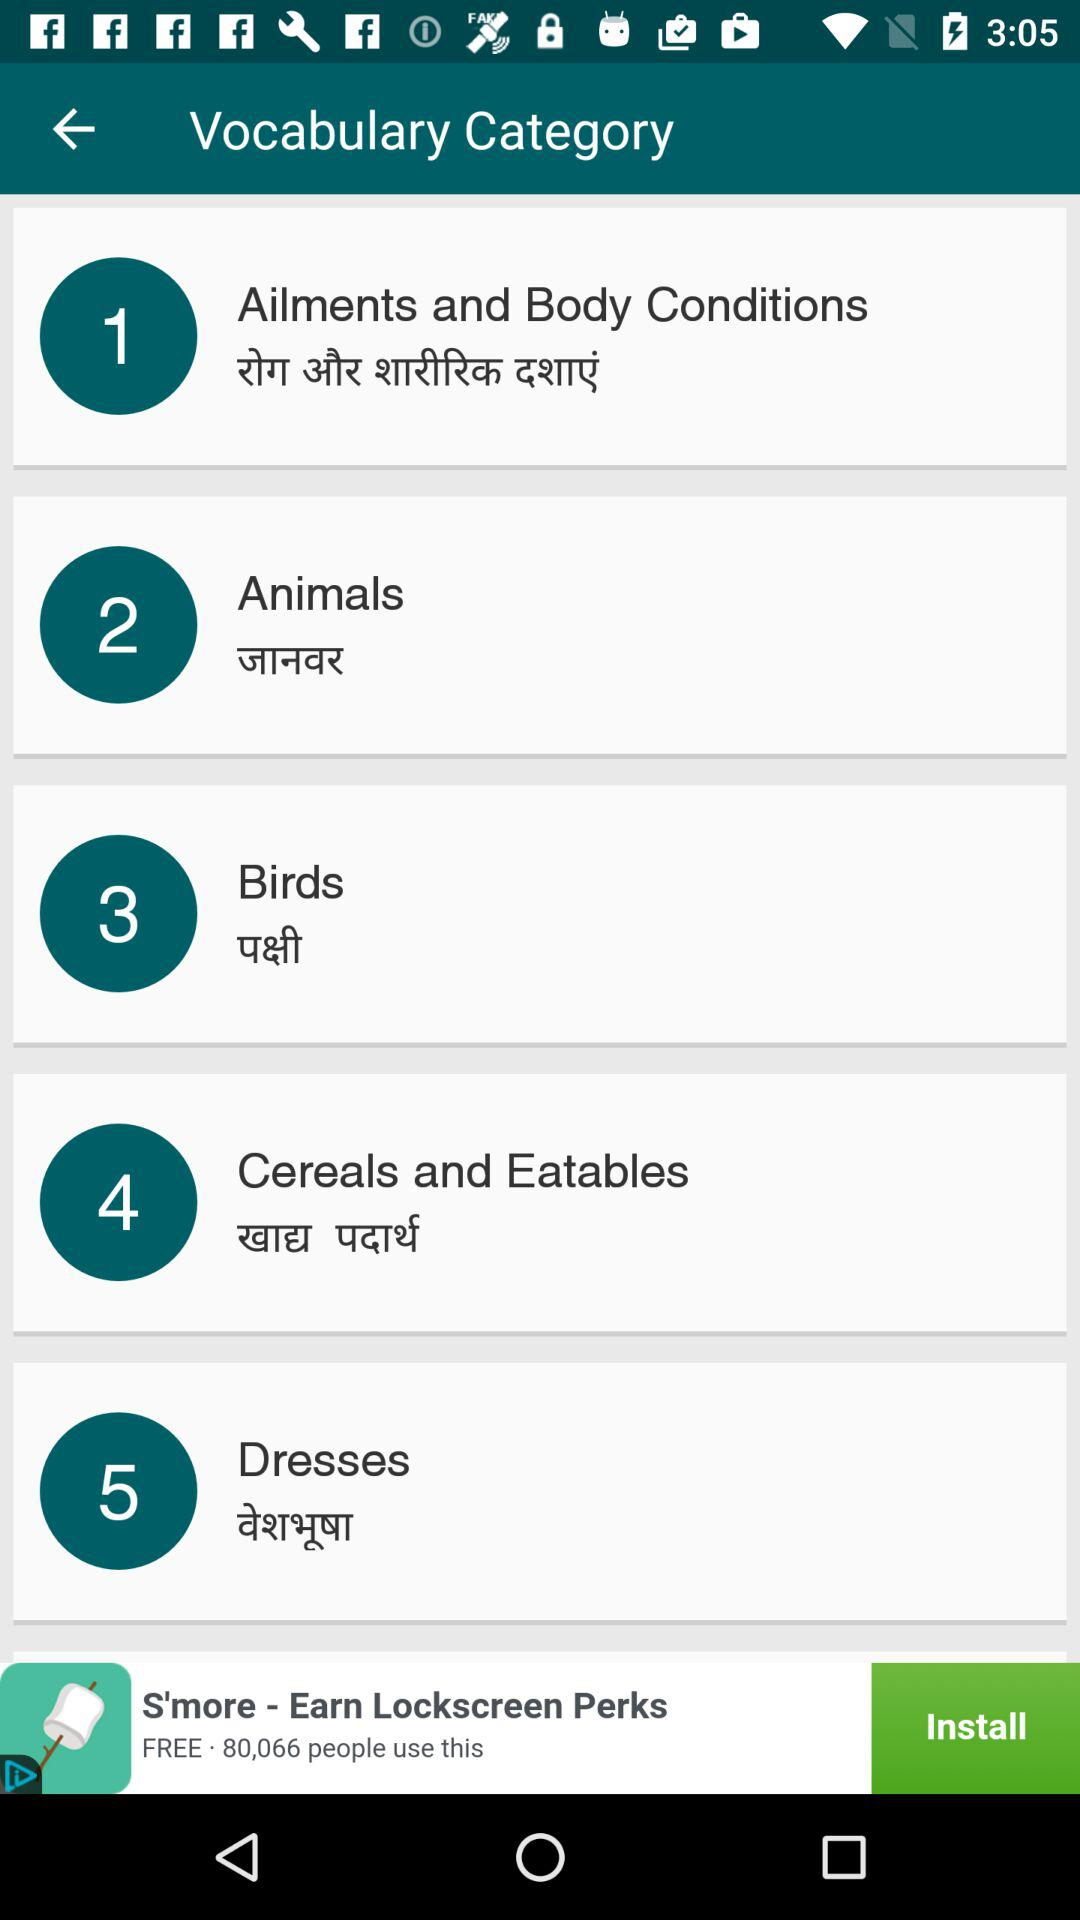How many categories are there?
Answer the question using a single word or phrase. 5 